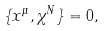Convert formula to latex. <formula><loc_0><loc_0><loc_500><loc_500>\{ x ^ { \mu } , { \chi } ^ { N } \} = 0 ,</formula> 